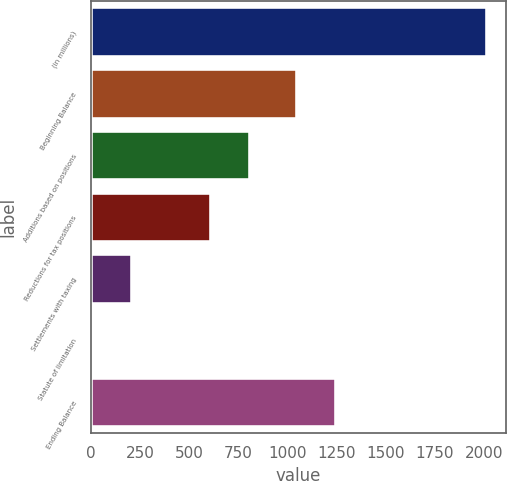Convert chart to OTSL. <chart><loc_0><loc_0><loc_500><loc_500><bar_chart><fcel>(in millions)<fcel>Beginning Balance<fcel>Additions based on positions<fcel>Reductions for tax positions<fcel>Settlements with taxing<fcel>Statute of limitation<fcel>Ending Balance<nl><fcel>2015<fcel>1047<fcel>810.2<fcel>609.4<fcel>207.8<fcel>7<fcel>1247.8<nl></chart> 